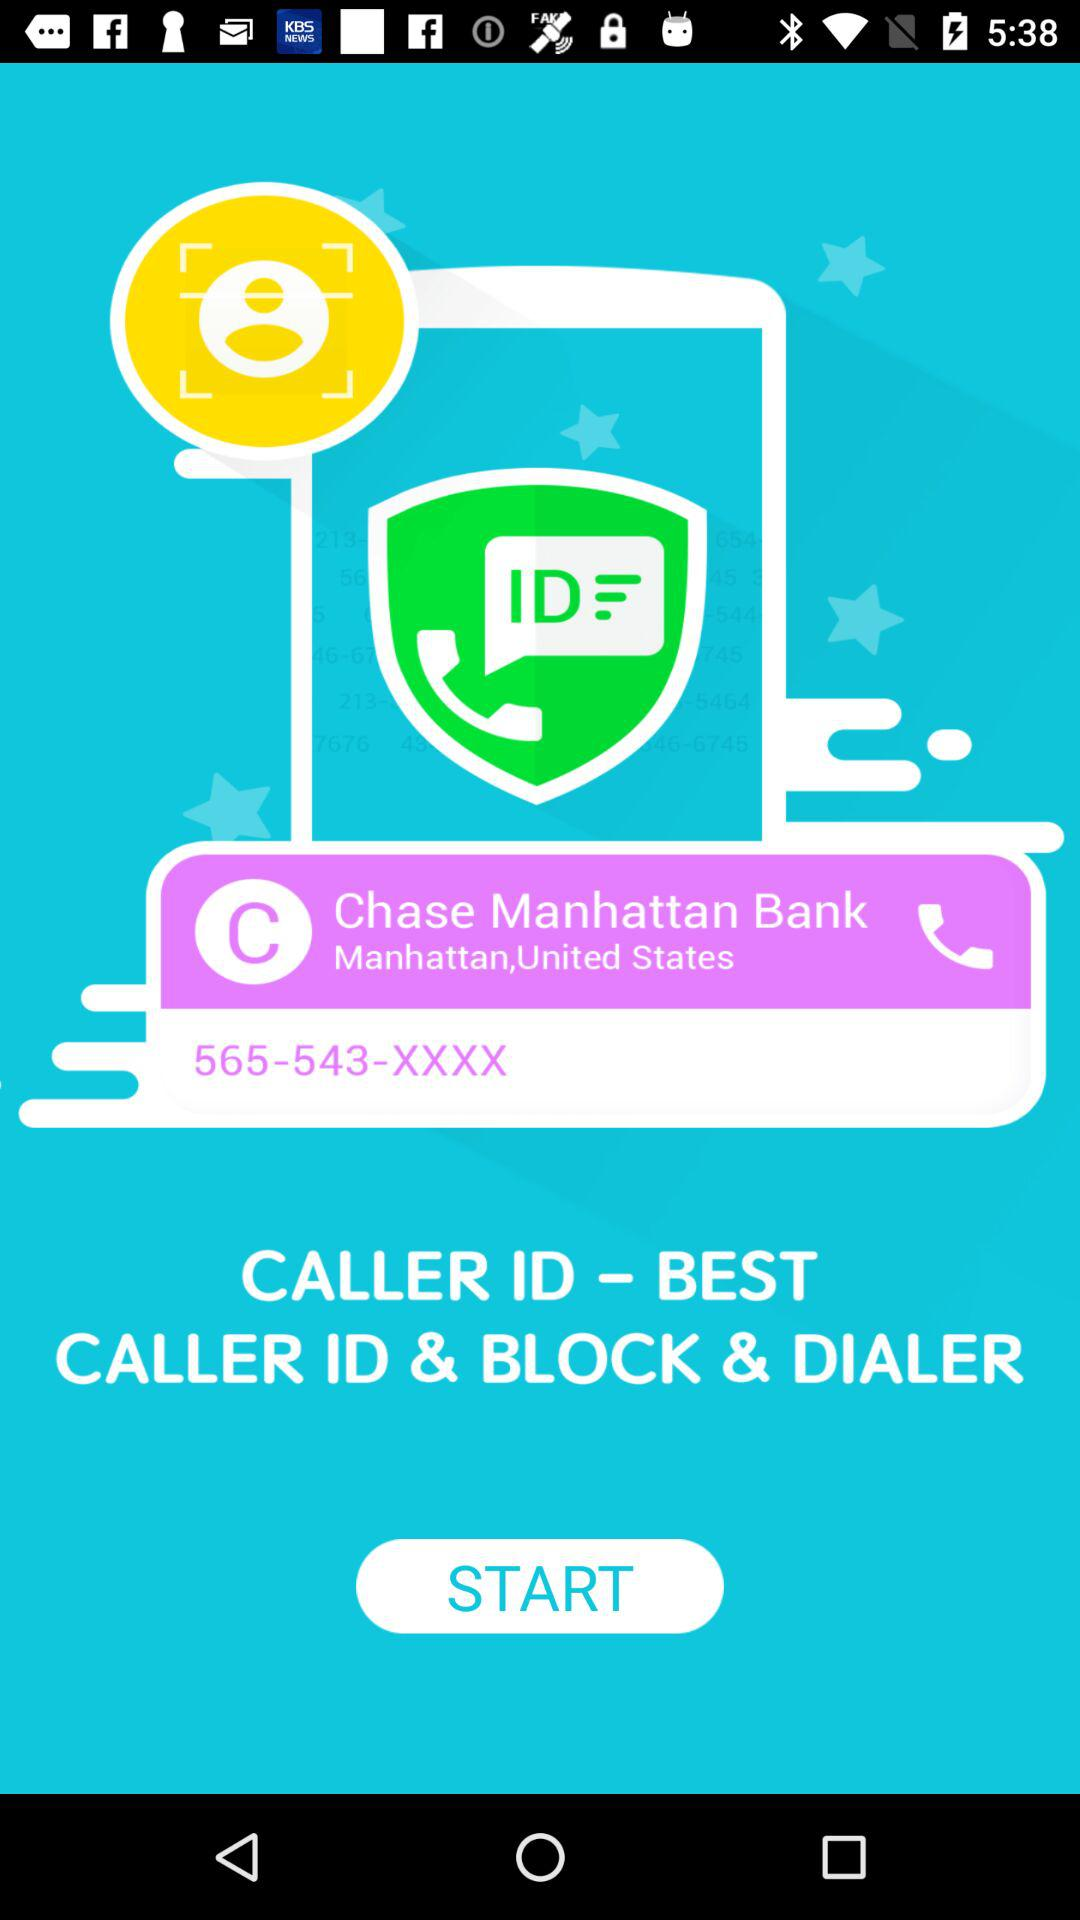What is the app name? The app name is "CALLER ID". 